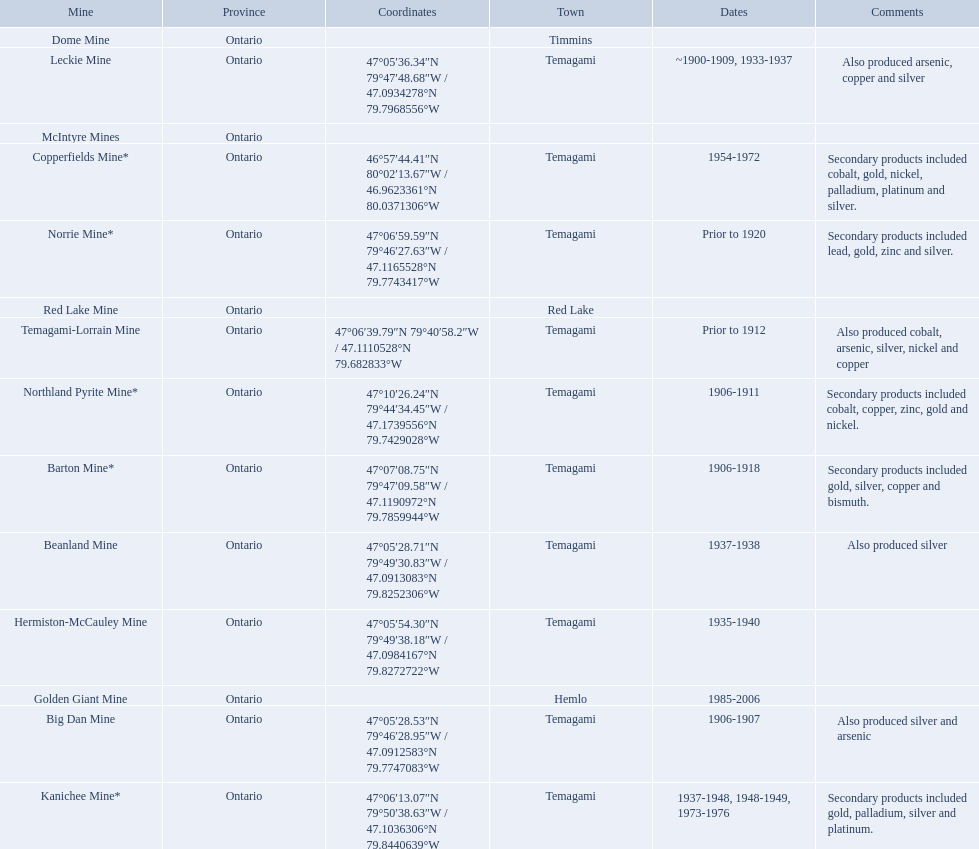What are all the mines with dates listed? Barton Mine*, Beanland Mine, Big Dan Mine, Copperfields Mine*, Golden Giant Mine, Hermiston-McCauley Mine, Kanichee Mine*, Leckie Mine, Norrie Mine*, Northland Pyrite Mine*, Temagami-Lorrain Mine. Which of those dates include the year that the mine was closed? 1906-1918, 1937-1938, 1906-1907, 1954-1972, 1985-2006, 1935-1940, 1937-1948, 1948-1949, 1973-1976, ~1900-1909, 1933-1937, 1906-1911. Which of those mines were opened the longest? Golden Giant Mine. 